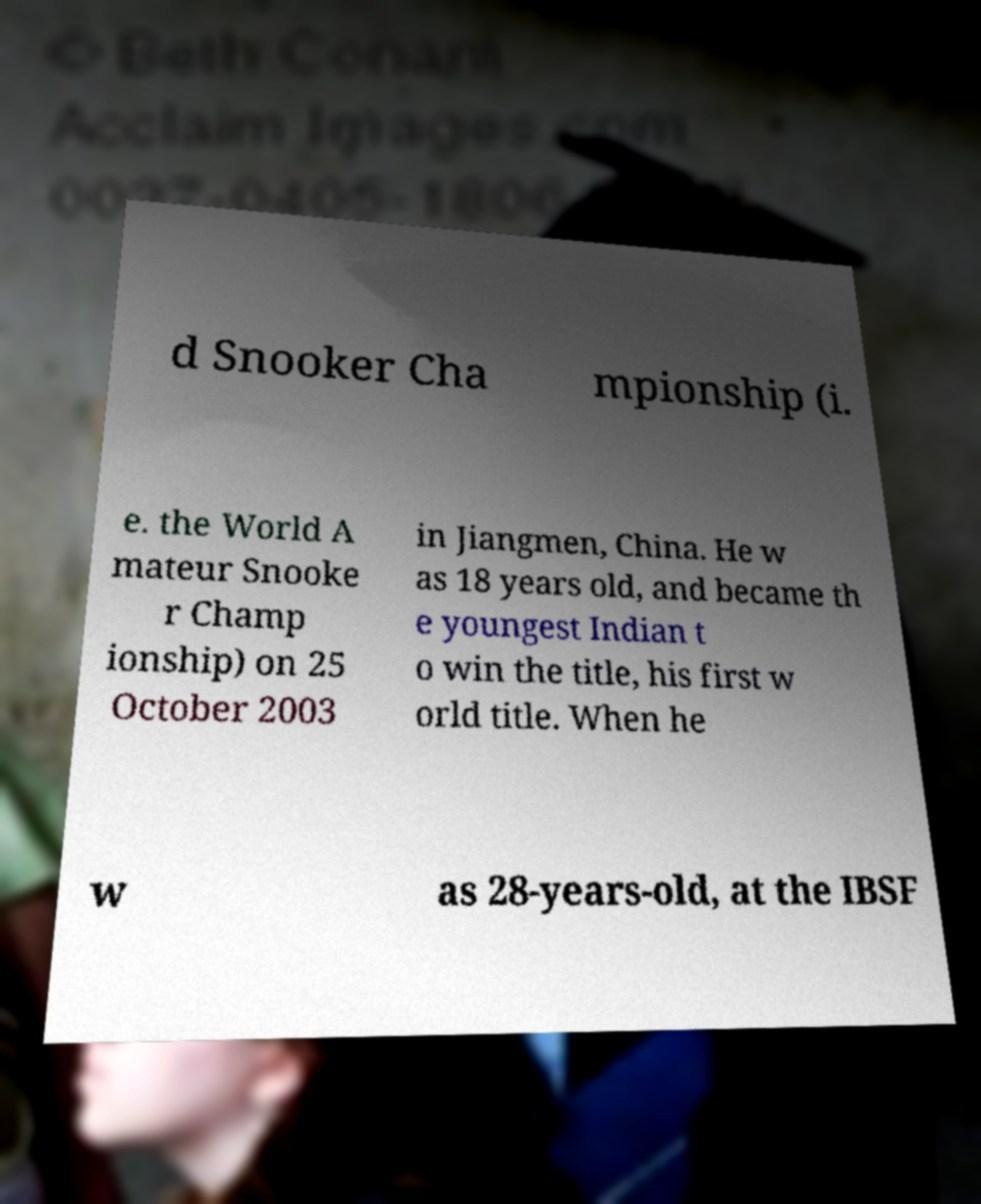What messages or text are displayed in this image? I need them in a readable, typed format. d Snooker Cha mpionship (i. e. the World A mateur Snooke r Champ ionship) on 25 October 2003 in Jiangmen, China. He w as 18 years old, and became th e youngest Indian t o win the title, his first w orld title. When he w as 28-years-old, at the IBSF 